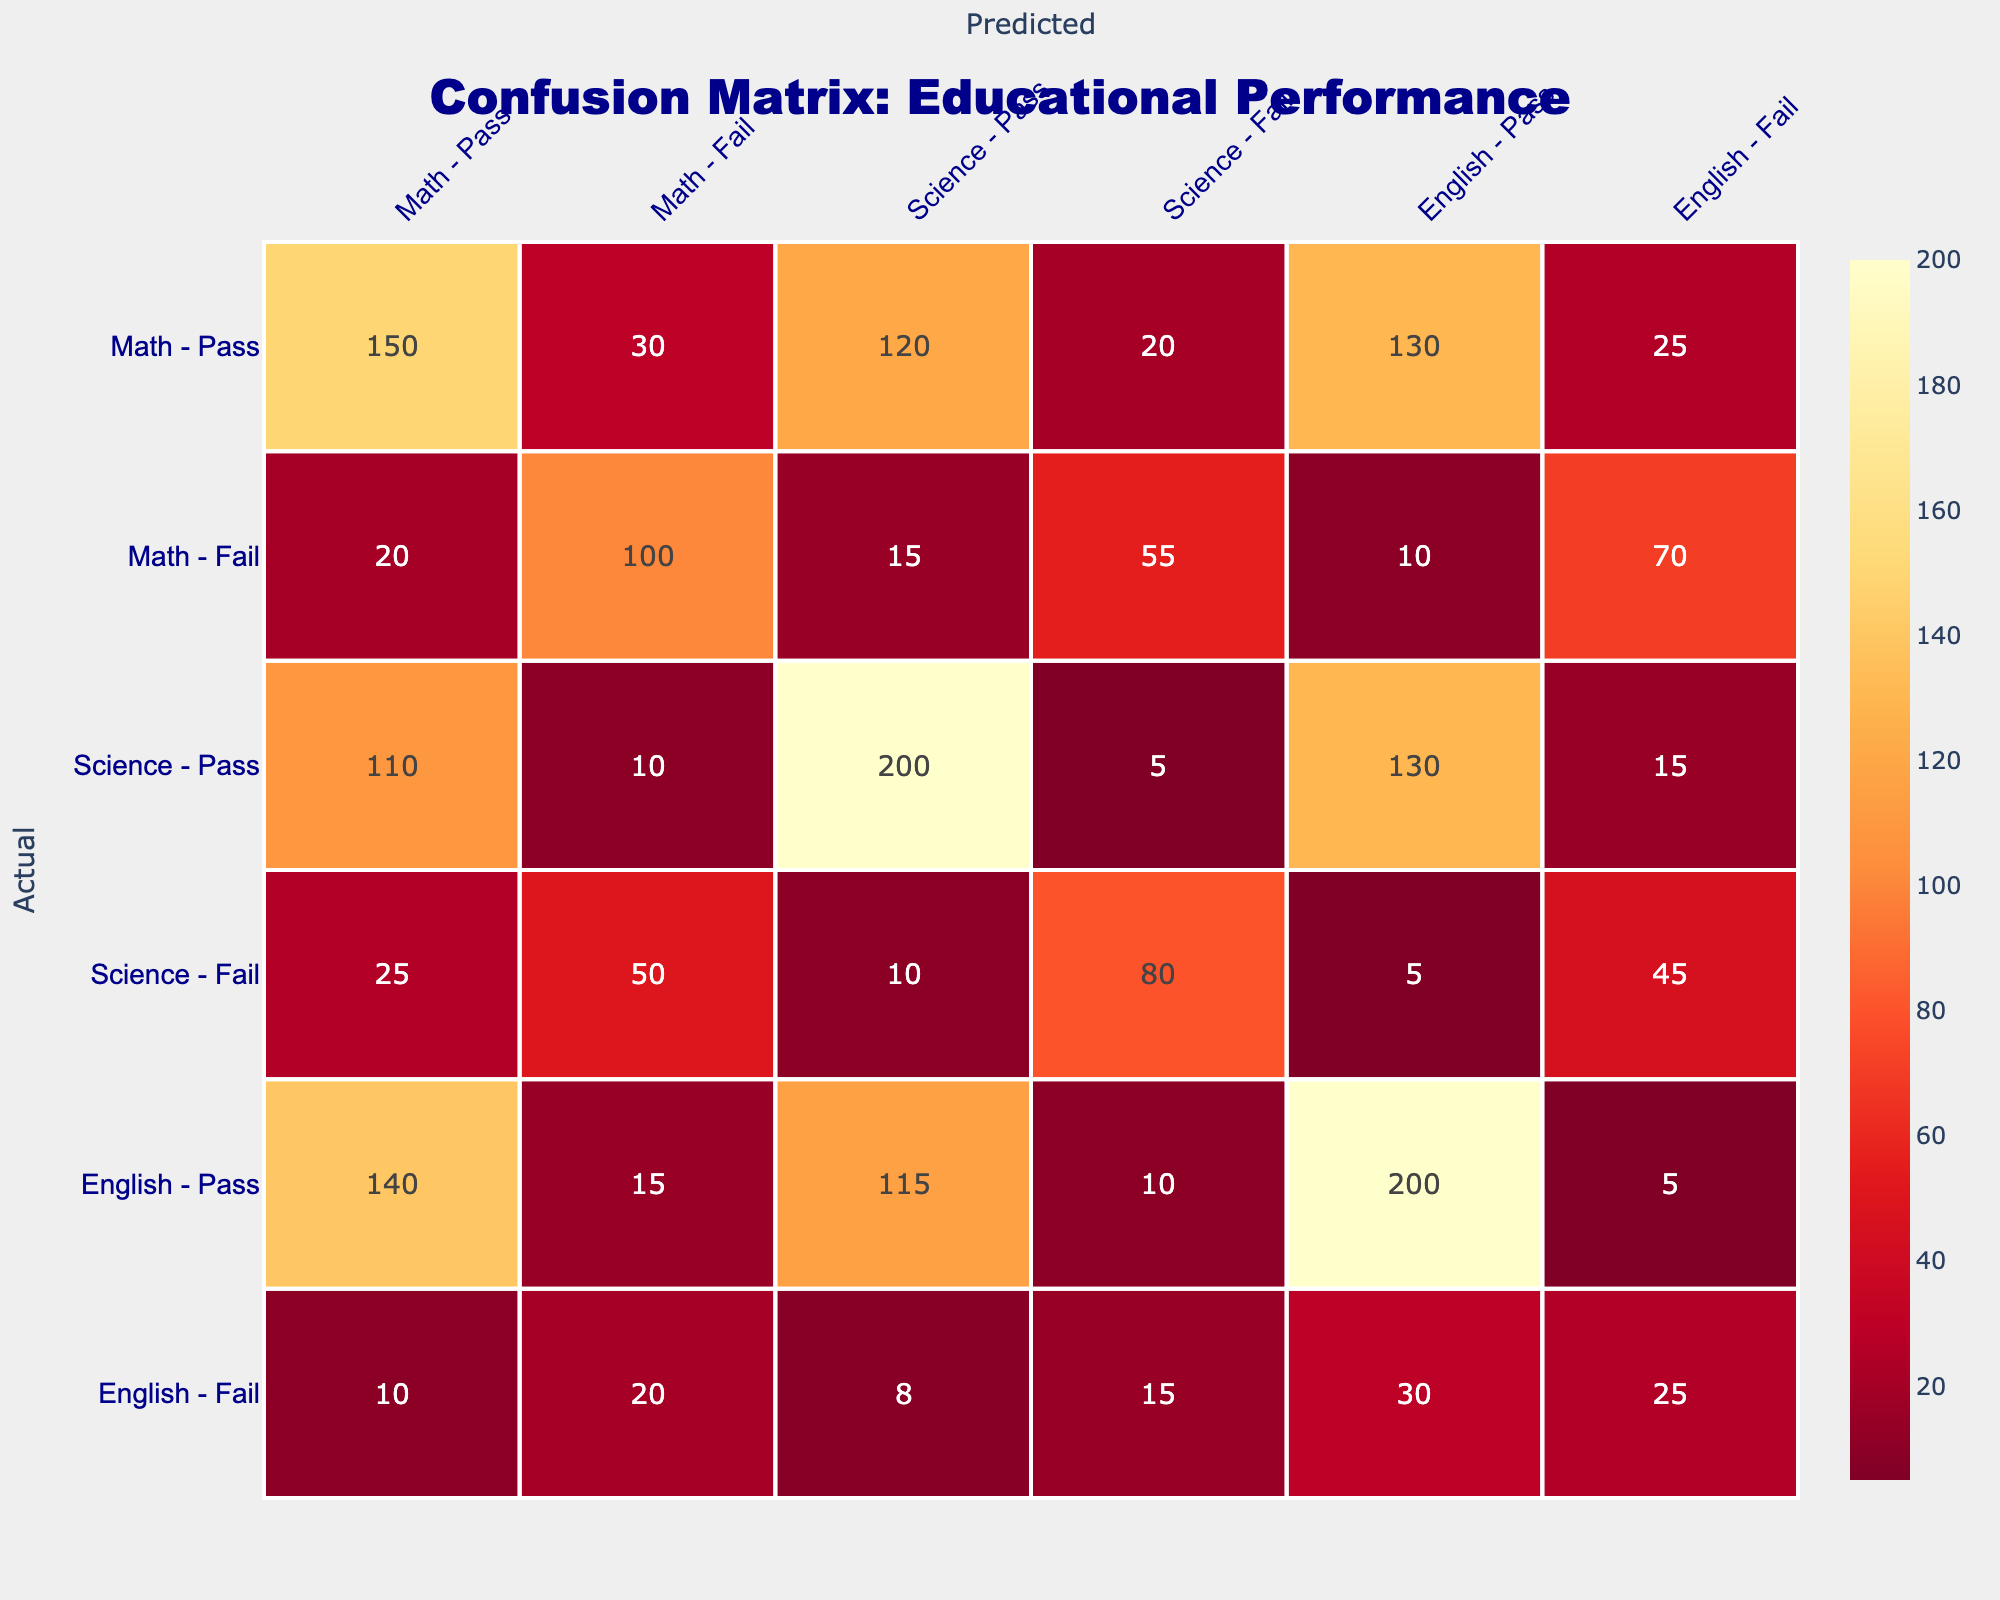What is the total number of students who passed Mathematics? To find the total number of students who passed Mathematics, we need to look at the values under the "Math - Pass" prediction row. The values are 150 (True Positives) for Math - Pass and 20 (False Negatives) for Math - Fail. Adding these gives us 150 + 20 = 170.
Answer: 170 How many students failed Science according to the predictions? Looking at the "Science - Fail" column, we find the values corresponding to both predicted passes and actual fails: 20 (False Positives) for Math and 80 (True Negatives) for Science - Fail. Therefore, the total number of students who failed Science is calculated as 20 + 80 = 100.
Answer: 100 Is it true that more students passed English than Science? We need to compare the total number of students passing English and Science. For English, we have 200 (True Positives) and for Science, we have 200 (True Positives). Since both pass rates are equal, the answer is no, more students did not pass English than Science.
Answer: No What is the total number of students who predicted to fail in English? To determine this, we refer to the "English - Fail" column. It consists of 5 (False Positives), 10 (True Negatives), 15 (False Negatives), and 30 (True Negatives), summing these values reveals: 5 + 10 + 15 + 30 = 60. Therefore, the total number of students predicted to fail in English is 60.
Answer: 60 What is the difference between the number of students who passed Math and those who passed Science? To find the difference, we need the totals of students who passed both subjects. From the table, Mathematics passes 170 students, while Science passes 200 students (adding 200 from True Positives). Therefore, the difference is 200 - 170 = 30.
Answer: 30 What is the average number of students passing Science? The number of students passing Science is stated as 200. Therefore, the average number of students passing Science is equal to this value because there's only one total in consideration, which is 200.
Answer: 200 How many students failed Mathematics compared to those who passed? To find this, we examine the Math data: there are 30 who are falsely predicted to fail Math and 100 who actually fail Math based on the confusion matrix (totaling 30 + 100 = 130). In comparision to those passing (150), here we note that passing exceeds failing (130 compares to 150), effectively confirming that fewer students failed Mathematics.
Answer: Fewer students failed Mathematics 